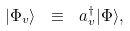Convert formula to latex. <formula><loc_0><loc_0><loc_500><loc_500>| \Phi _ { v } \rangle \ \equiv \ a _ { v } ^ { \dag } | \Phi \rangle ,</formula> 